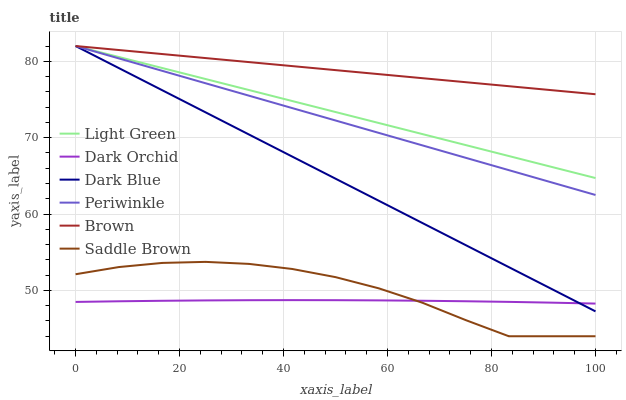Does Dark Blue have the minimum area under the curve?
Answer yes or no. No. Does Dark Blue have the maximum area under the curve?
Answer yes or no. No. Is Dark Orchid the smoothest?
Answer yes or no. No. Is Dark Orchid the roughest?
Answer yes or no. No. Does Dark Orchid have the lowest value?
Answer yes or no. No. Does Dark Orchid have the highest value?
Answer yes or no. No. Is Dark Orchid less than Periwinkle?
Answer yes or no. Yes. Is Brown greater than Saddle Brown?
Answer yes or no. Yes. Does Dark Orchid intersect Periwinkle?
Answer yes or no. No. 